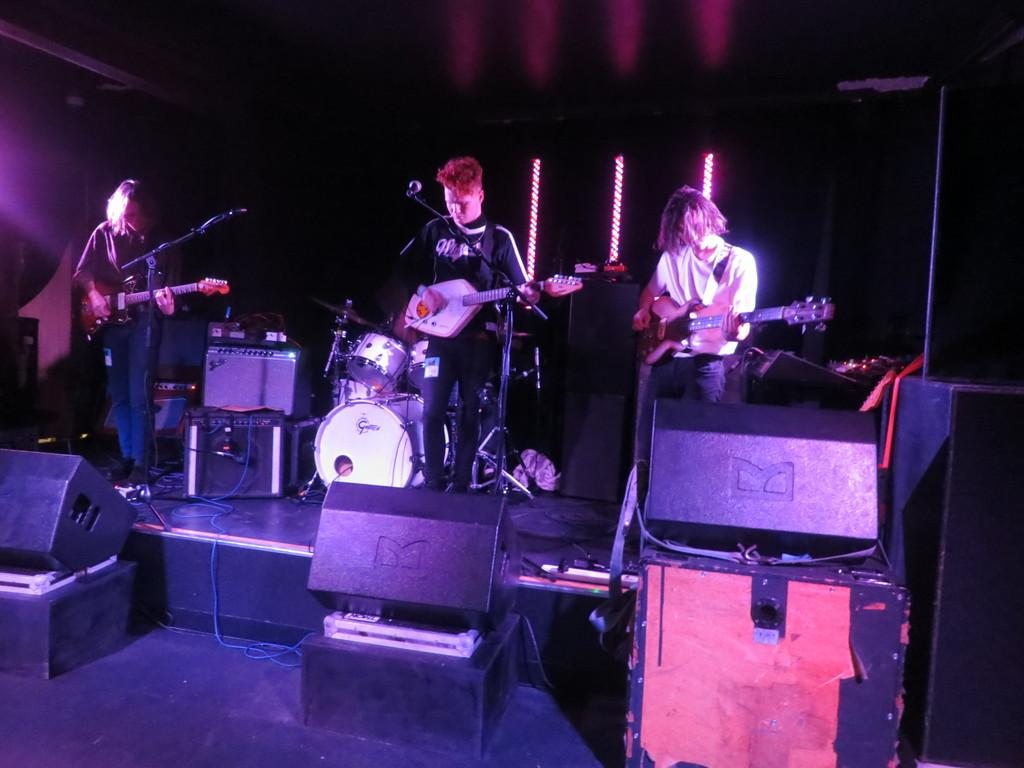How many people are in the image? There are three people in the image. What are the people doing in the image? The people are standing in front of a microphone and holding musical instruments. What else can be seen in the image besides the people? There are musical instruments visible in the image. Can you see any veins on the wren in the image? There is no wren present in the image; it features three people holding musical instruments. 